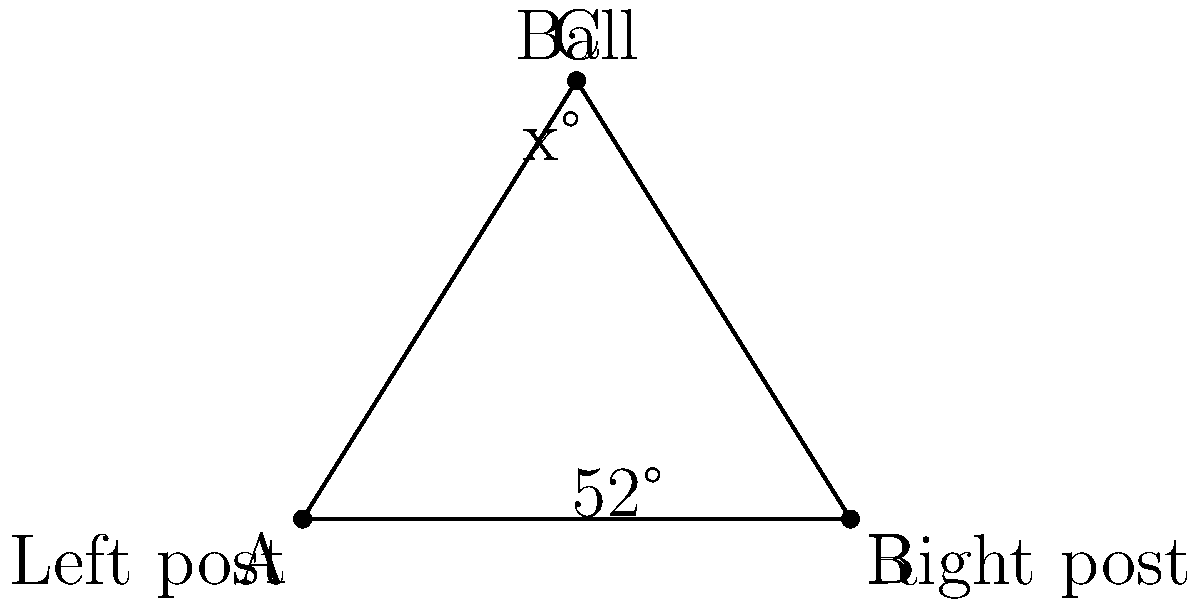In a crucial match, Khalil Bader is preparing to take a corner kick. The ball is positioned at point C, and the goal posts are at points A and B. Given that angle CAB is 52°, what is the measure of angle ACB (represented by x° in the diagram)? Let's solve this step-by-step:

1) In any triangle, the sum of all interior angles is always 180°.

2) We are given that angle CAB is 52°.

3) We need to find angle ACB, which we'll call x°.

4) Let's call the third angle (ABC) y°.

5) We can set up an equation based on the fact that the sum of the angles in a triangle is 180°:
   
   $52° + x° + y° = 180°$

6) We also know that in an isosceles triangle, the angles opposite the equal sides are equal. Since CA and CB are both from the corner to the goal posts, they are likely equal, making this an isosceles triangle.

7) If the triangle is isosceles, then angle CAB = angle CBA. We know CAB is 52°, so CBA must also be 52°.

8) Substituting this into our equation:
   
   $52° + x° + 52° = 180°$

9) Simplifying:
   
   $104° + x° = 180°$

10) Solving for x:
    
    $x° = 180° - 104° = 76°$

Therefore, the measure of angle ACB is 76°.
Answer: 76° 